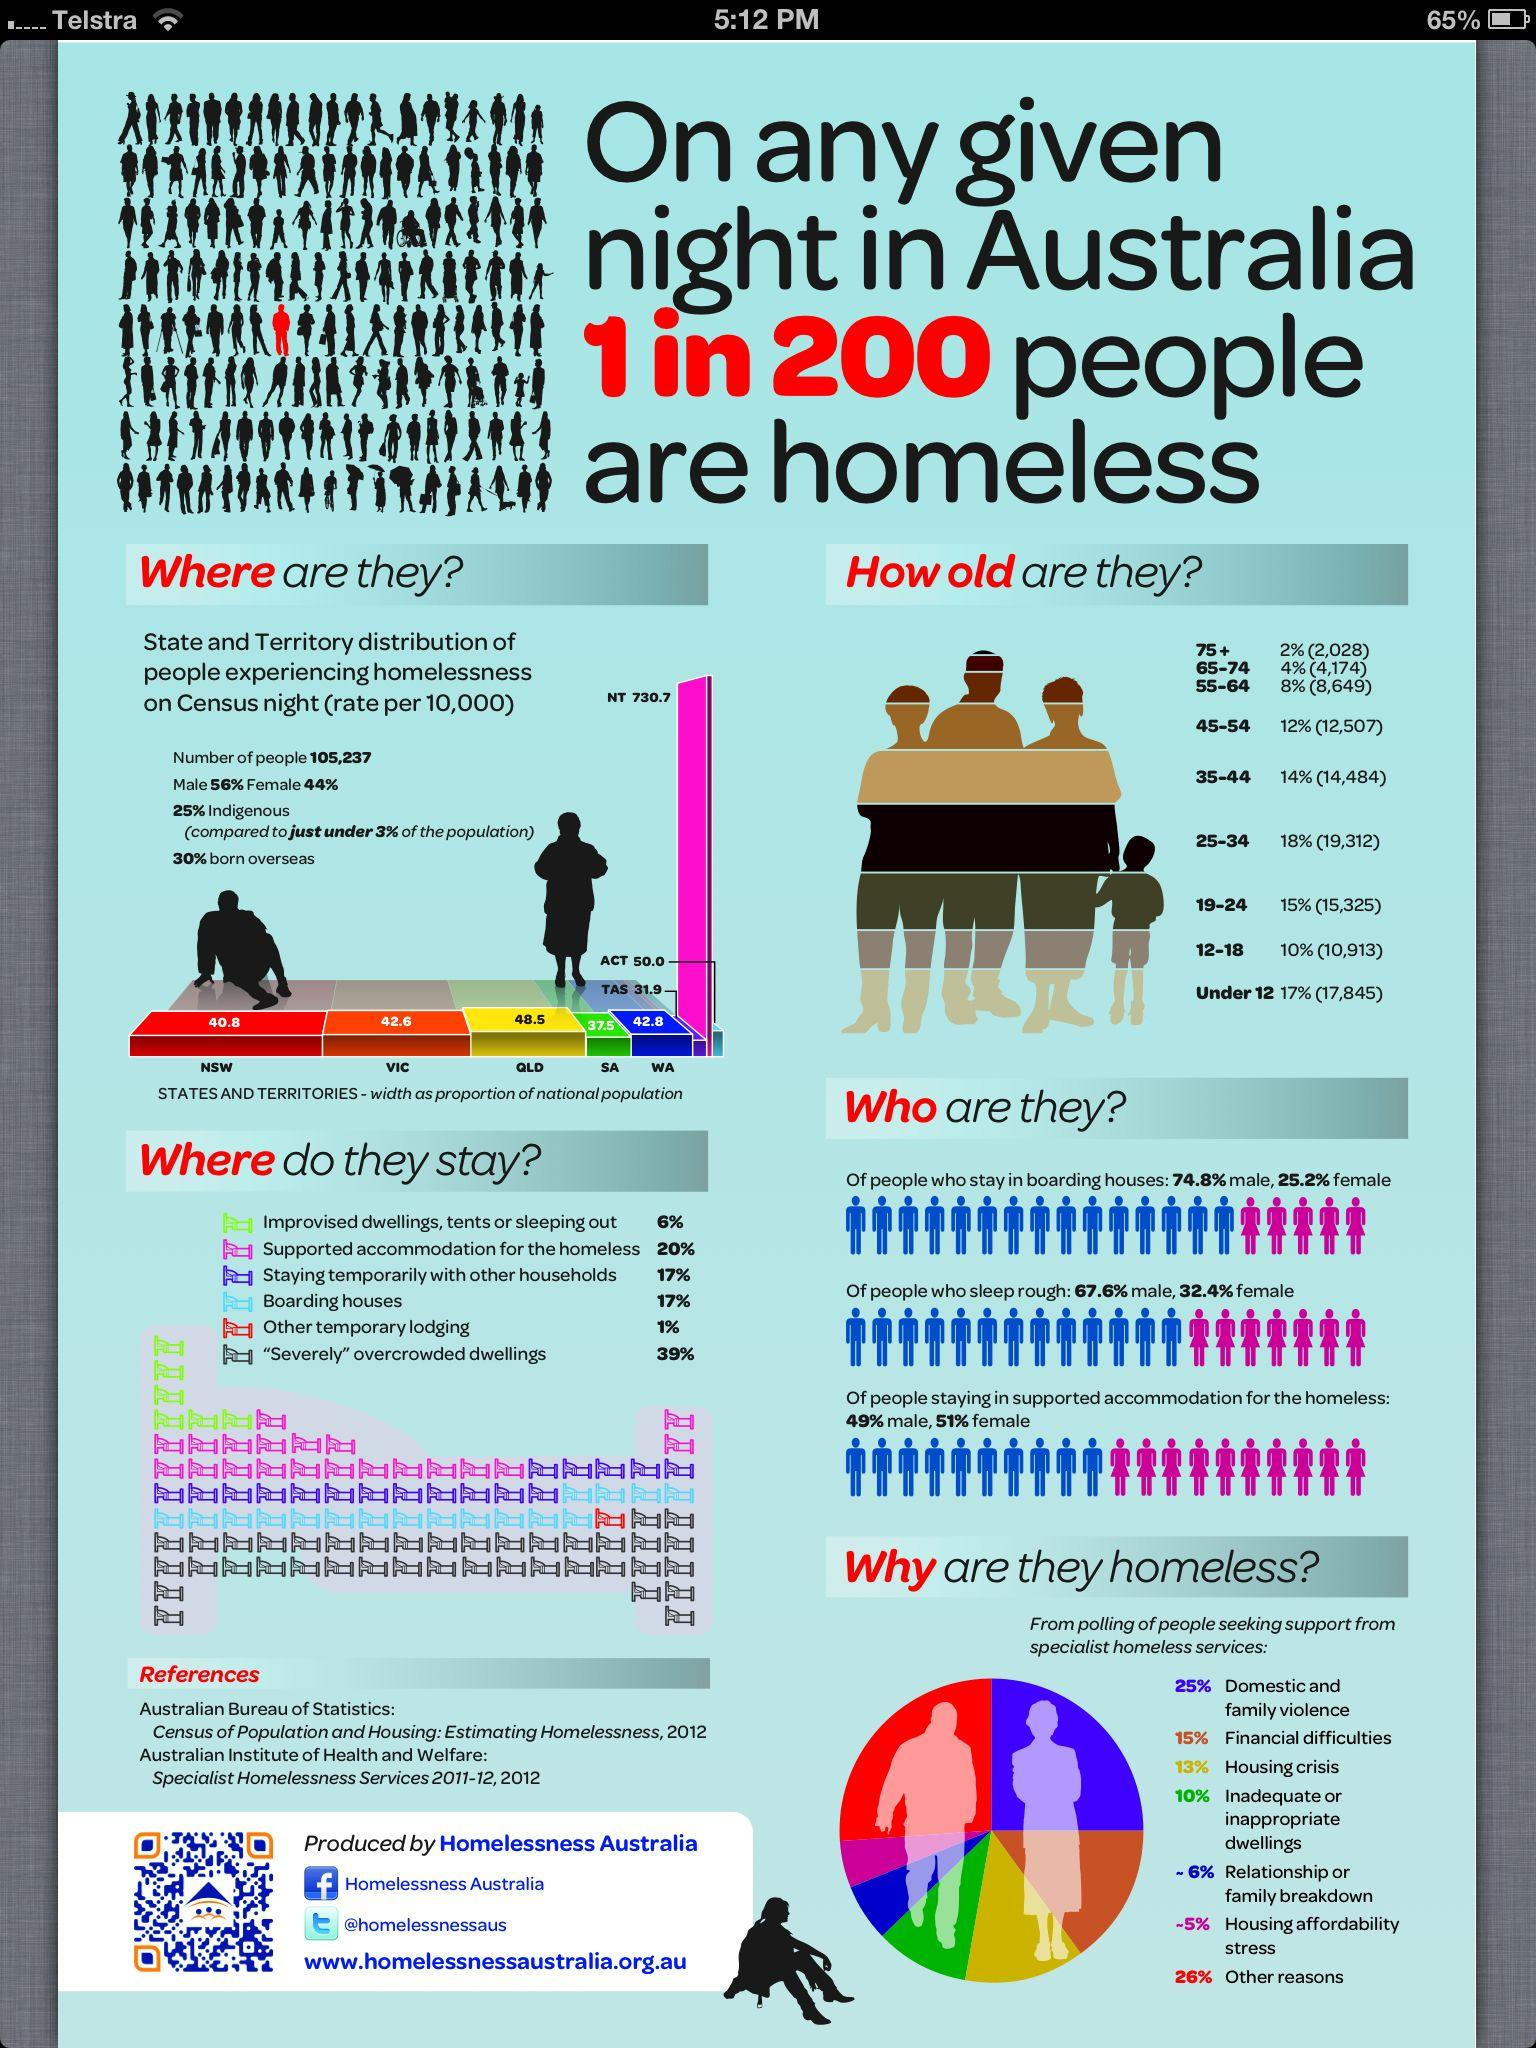Identify some key points in this picture. The third most common reason given by individuals for being homeless was financial difficulties. In a survey of the homeless population, a quarter of respondents reported that the primary reason for their homelessness was due to domestic and family violence. According to data, approximately 14% of homeless individuals are aged 55 and above. According to the second lowest percentage of people, the primary reason for homelessness is relationship or family breakdown. According to a recent study, the majority of homeless individuals belong to the age group of 25-34. 